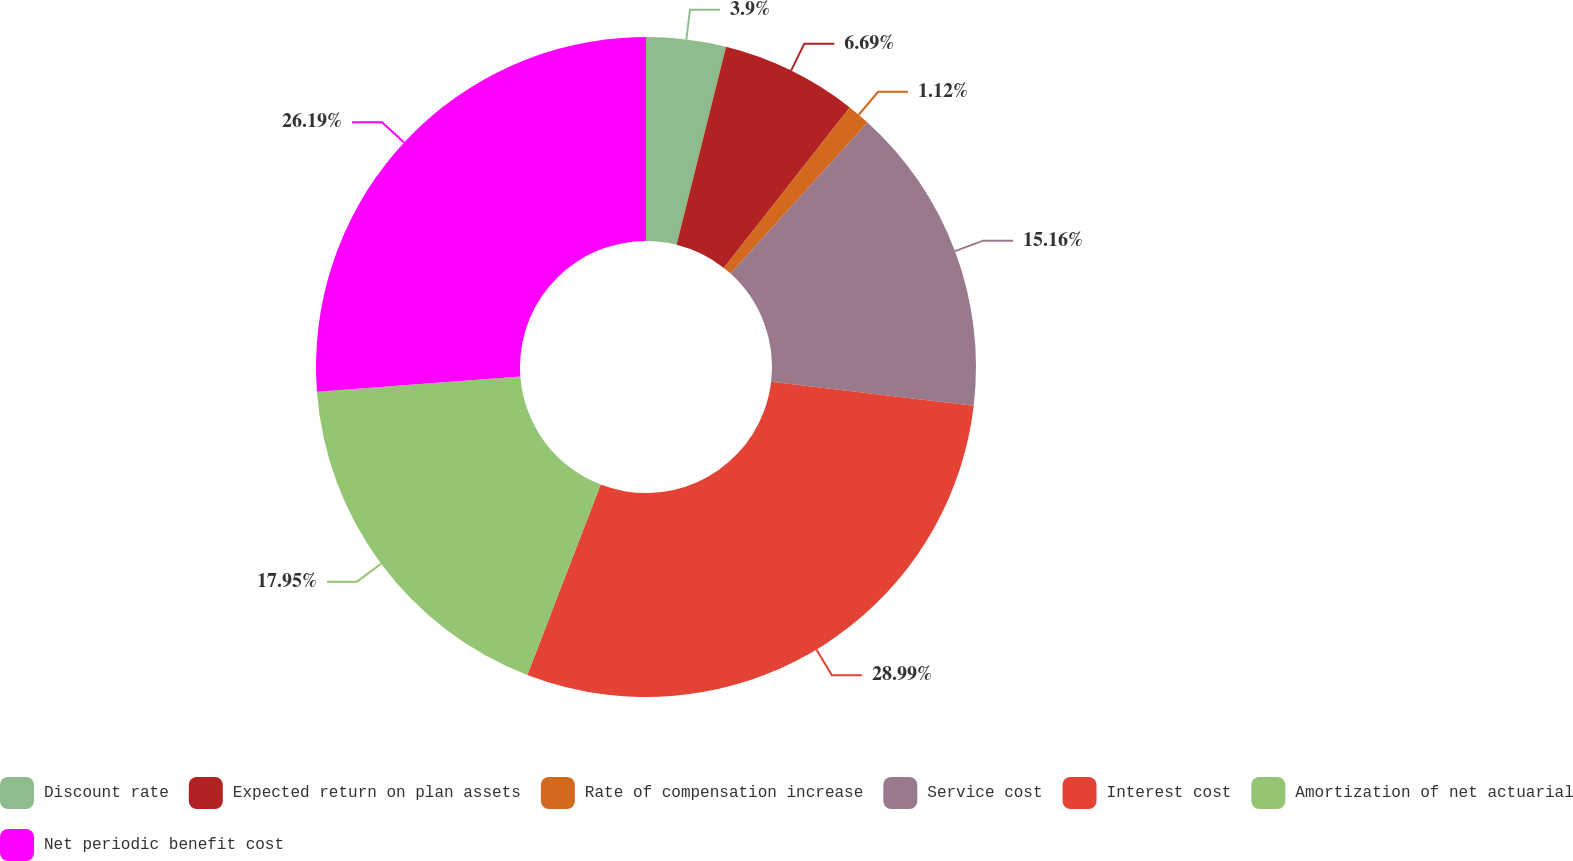<chart> <loc_0><loc_0><loc_500><loc_500><pie_chart><fcel>Discount rate<fcel>Expected return on plan assets<fcel>Rate of compensation increase<fcel>Service cost<fcel>Interest cost<fcel>Amortization of net actuarial<fcel>Net periodic benefit cost<nl><fcel>3.9%<fcel>6.69%<fcel>1.12%<fcel>15.16%<fcel>28.98%<fcel>17.95%<fcel>26.19%<nl></chart> 